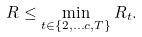Convert formula to latex. <formula><loc_0><loc_0><loc_500><loc_500>R \leq \min _ { t \in \{ 2 , \dots c , T \} } R _ { t } .</formula> 